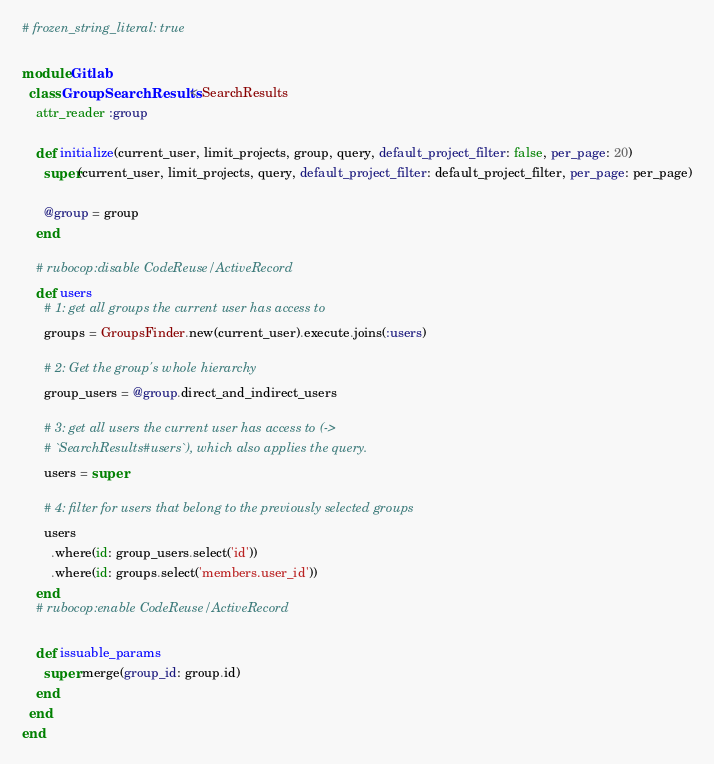<code> <loc_0><loc_0><loc_500><loc_500><_Ruby_># frozen_string_literal: true

module Gitlab
  class GroupSearchResults < SearchResults
    attr_reader :group

    def initialize(current_user, limit_projects, group, query, default_project_filter: false, per_page: 20)
      super(current_user, limit_projects, query, default_project_filter: default_project_filter, per_page: per_page)

      @group = group
    end

    # rubocop:disable CodeReuse/ActiveRecord
    def users
      # 1: get all groups the current user has access to
      groups = GroupsFinder.new(current_user).execute.joins(:users)

      # 2: Get the group's whole hierarchy
      group_users = @group.direct_and_indirect_users

      # 3: get all users the current user has access to (->
      # `SearchResults#users`), which also applies the query.
      users = super

      # 4: filter for users that belong to the previously selected groups
      users
        .where(id: group_users.select('id'))
        .where(id: groups.select('members.user_id'))
    end
    # rubocop:enable CodeReuse/ActiveRecord

    def issuable_params
      super.merge(group_id: group.id)
    end
  end
end
</code> 